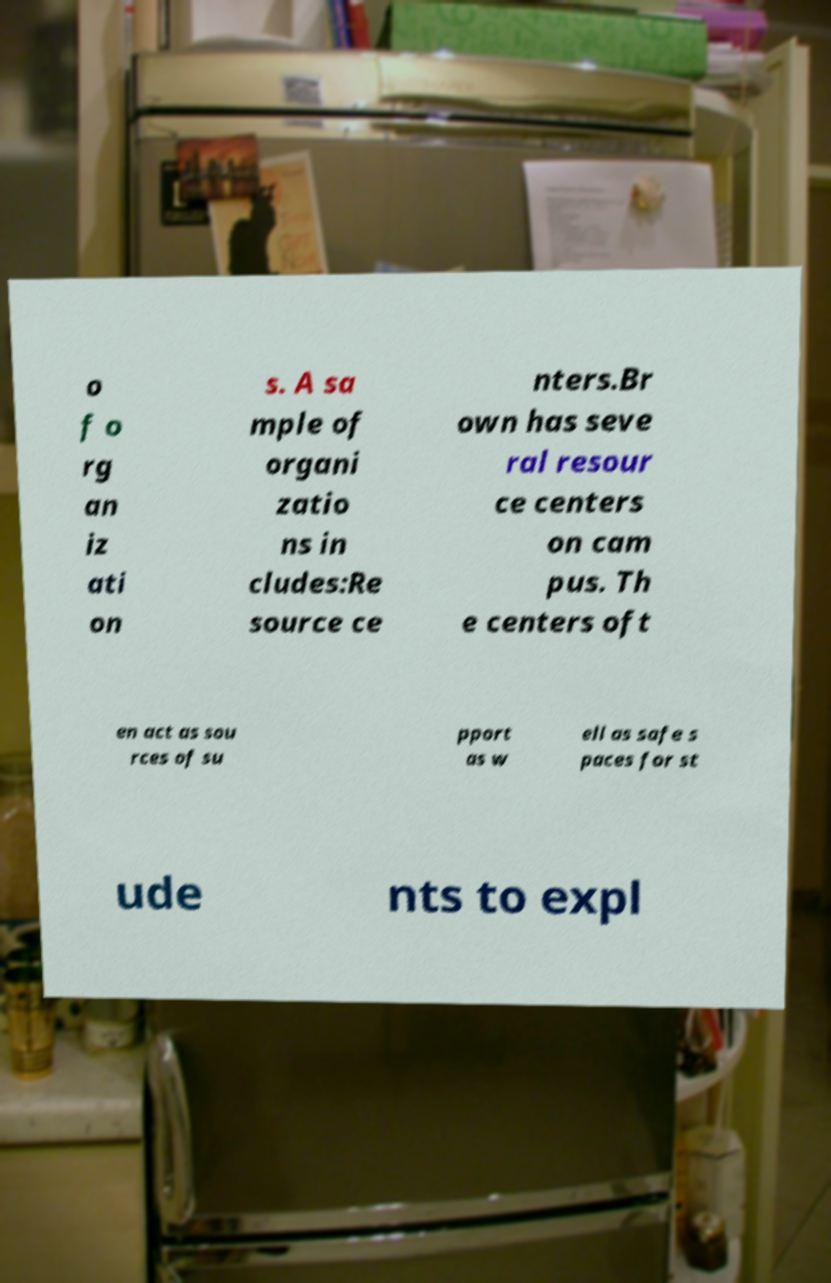Can you accurately transcribe the text from the provided image for me? o f o rg an iz ati on s. A sa mple of organi zatio ns in cludes:Re source ce nters.Br own has seve ral resour ce centers on cam pus. Th e centers oft en act as sou rces of su pport as w ell as safe s paces for st ude nts to expl 